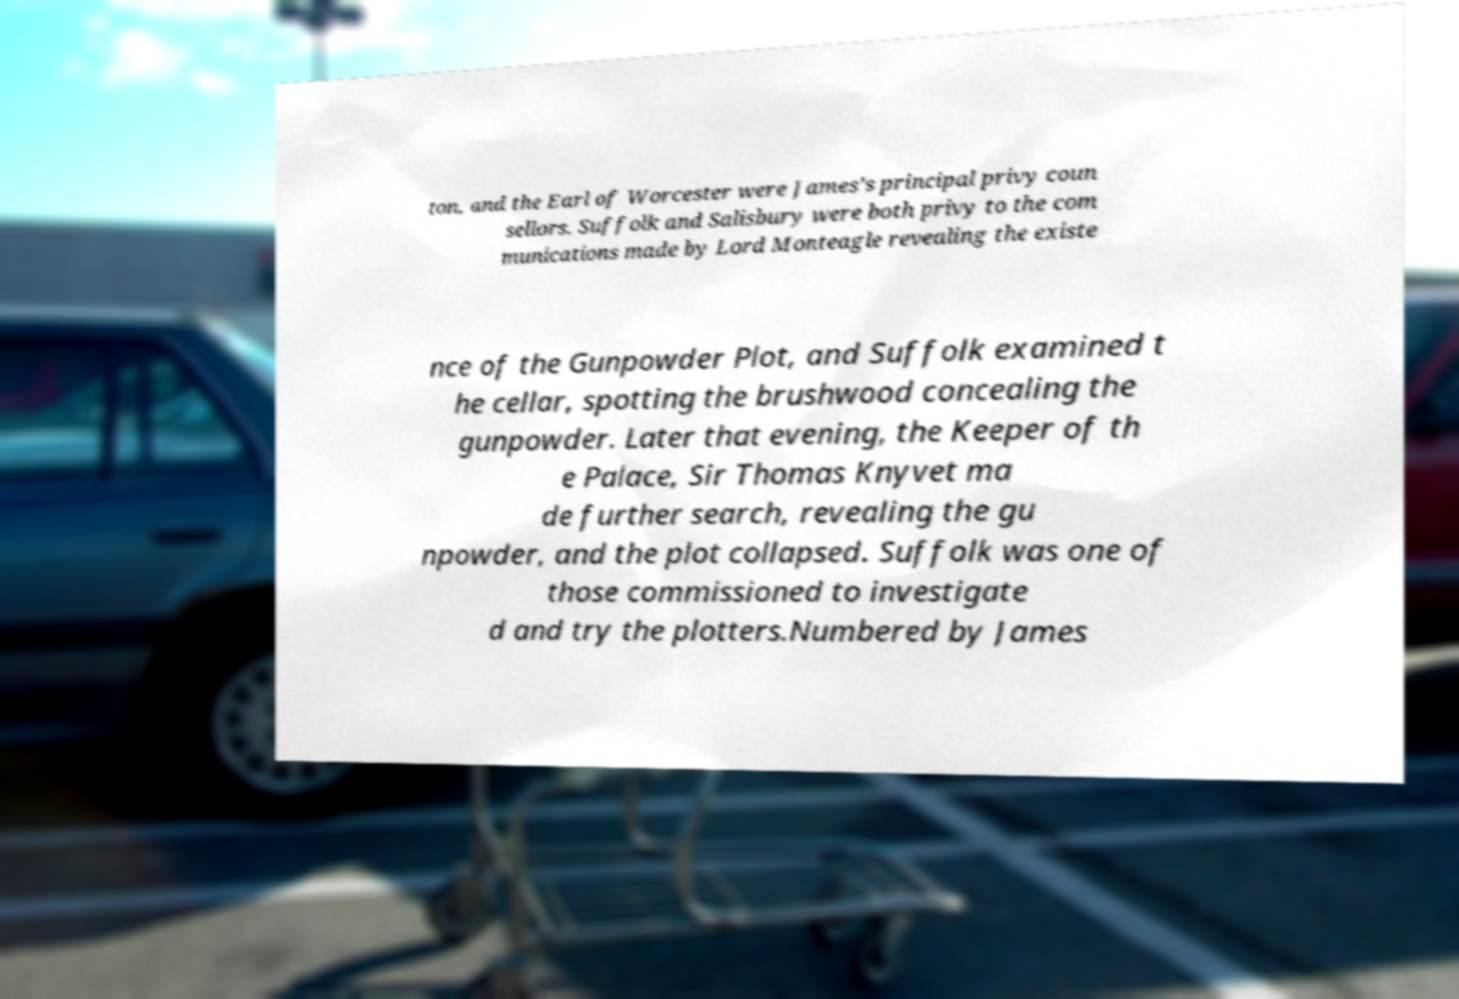Could you assist in decoding the text presented in this image and type it out clearly? ton, and the Earl of Worcester were James's principal privy coun sellors. Suffolk and Salisbury were both privy to the com munications made by Lord Monteagle revealing the existe nce of the Gunpowder Plot, and Suffolk examined t he cellar, spotting the brushwood concealing the gunpowder. Later that evening, the Keeper of th e Palace, Sir Thomas Knyvet ma de further search, revealing the gu npowder, and the plot collapsed. Suffolk was one of those commissioned to investigate d and try the plotters.Numbered by James 